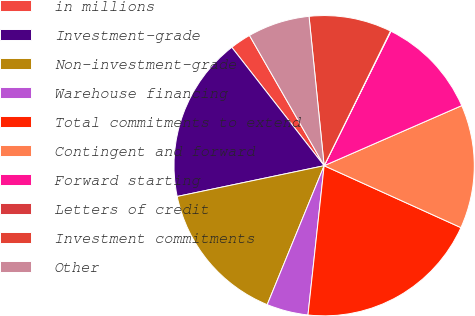Convert chart. <chart><loc_0><loc_0><loc_500><loc_500><pie_chart><fcel>in millions<fcel>Investment-grade<fcel>Non-investment-grade<fcel>Warehouse financing<fcel>Total commitments to extend<fcel>Contingent and forward<fcel>Forward starting<fcel>Letters of credit<fcel>Investment commitments<fcel>Other<nl><fcel>2.26%<fcel>17.74%<fcel>15.53%<fcel>4.47%<fcel>19.95%<fcel>13.32%<fcel>11.11%<fcel>0.05%<fcel>8.89%<fcel>6.68%<nl></chart> 